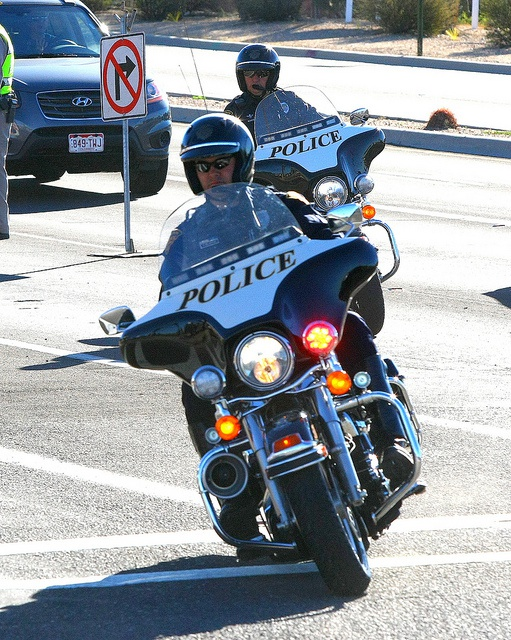Describe the objects in this image and their specific colors. I can see motorcycle in lightblue, black, navy, and blue tones, car in lightblue, black, darkblue, blue, and navy tones, motorcycle in lightblue, white, black, blue, and navy tones, people in lightblue, black, navy, white, and gray tones, and people in lightblue, black, navy, gray, and darkblue tones in this image. 